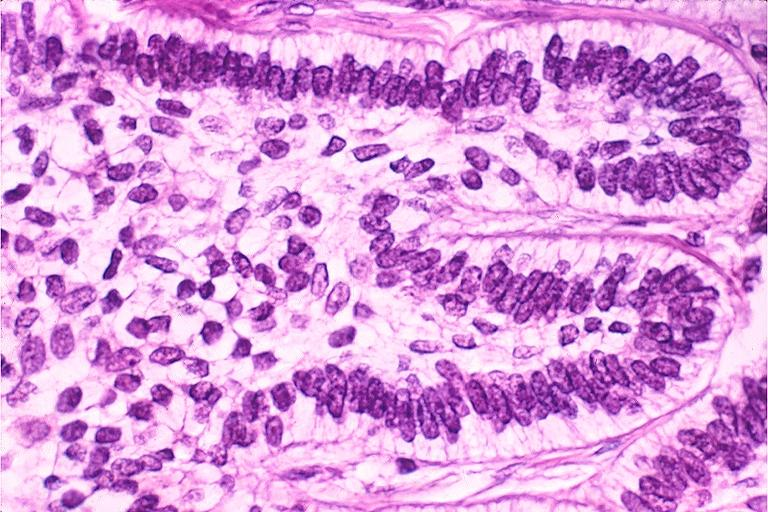s notochord present?
Answer the question using a single word or phrase. No 